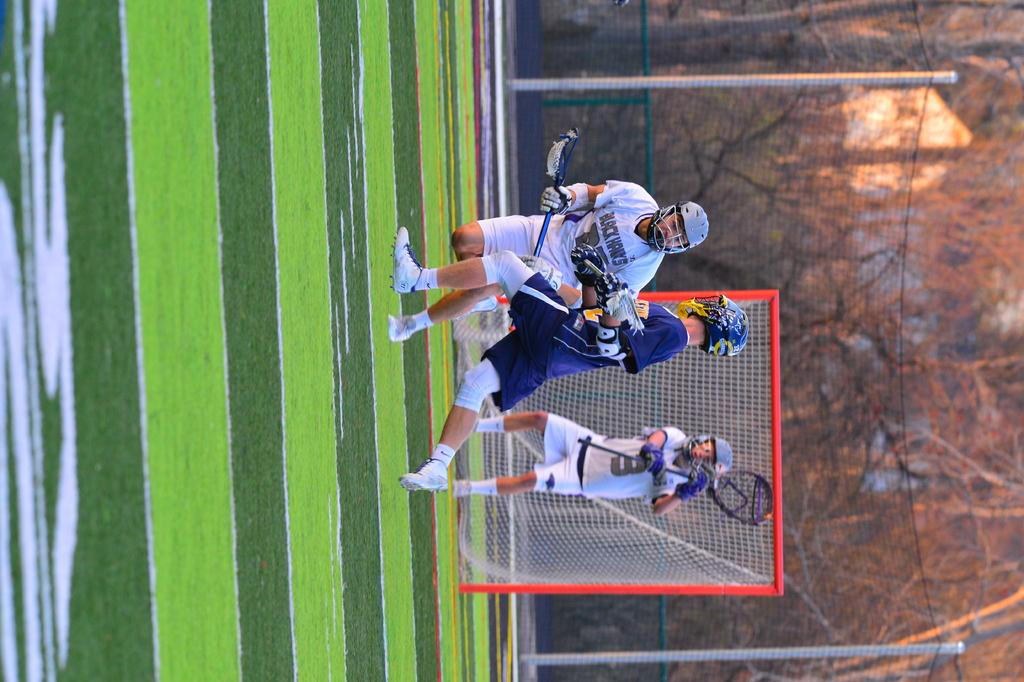How many people are in the image? There are three people in the image. What protective gear are the people wearing? The people are wearing helmets and goggles. What objects are the people holding? The people are holding bats. What is present in the image to catch or deflect the objects being hit? There is a net in the image. What type of surface is visible in the image? There is grass on the ground in the image. What can be seen in the background of the image? There are trees in the background of the image. What channel is the people watching on the television in the image? There is no television present in the image; the people are engaged in an outdoor activity. 